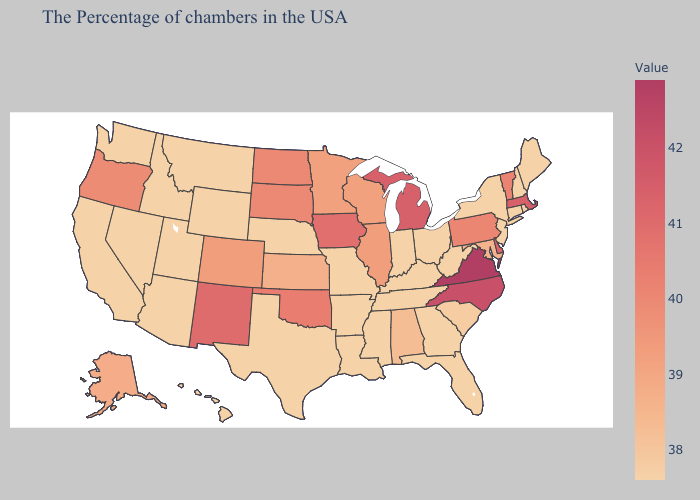Does Minnesota have the highest value in the MidWest?
Write a very short answer. No. Does Nebraska have a higher value than North Carolina?
Write a very short answer. No. Does Massachusetts have a higher value than Alabama?
Write a very short answer. Yes. 